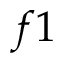<formula> <loc_0><loc_0><loc_500><loc_500>f 1</formula> 